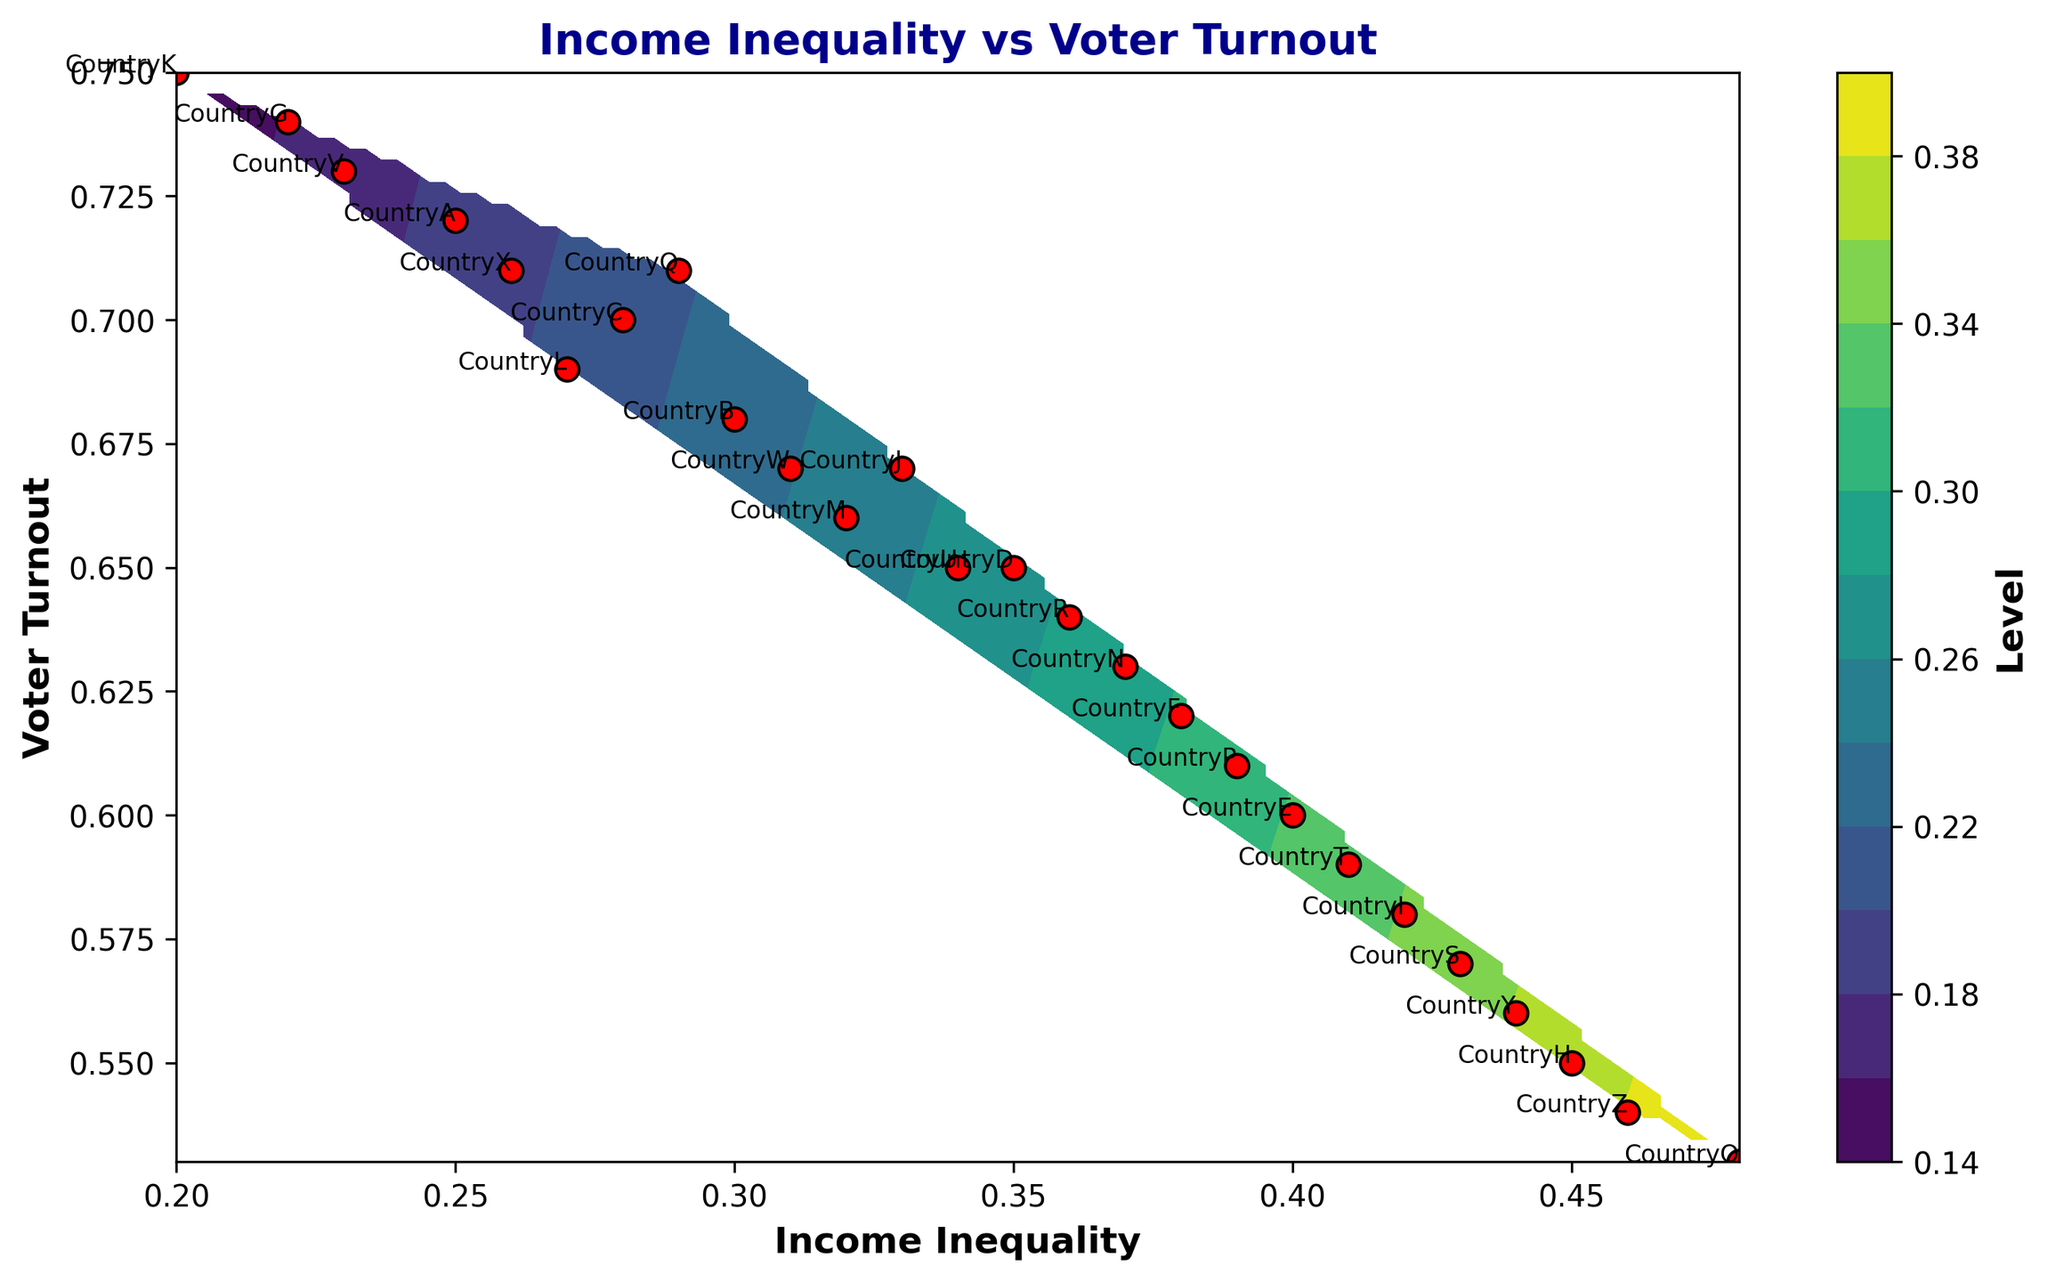What is the general trend between income inequality and voter turnout? By looking at the contour plot, the general trend appears to be that as income inequality increases, voter turnout tends to decrease. This is portrayed by the overall direction and shape of the contours.
Answer: As income inequality increases, voter turnout decreases Which country exhibits the highest voter turnout, and what is its corresponding income inequality? Referencing the scatter points on the plot, the country with the highest voter turnout is CountryK (0.75), which has an income inequality of 0.20.
Answer: CountryK; Income inequality 0.20 Which country has the highest income inequality, and what is its voter turnout rate? Observing the scatter points, CountryO has the highest income inequality at 0.48, and its corresponding voter turnout rate is 0.53.
Answer: CountryO; Voter turnout 0.53 What countries fall within the top 50% of the income inequality spectrum? Countries with the highest income inequalities are identified by values close to 0.48. These countries include CountryO, CountryZ, CountryY, CountryS, CountryT, and CountryI.
Answer: CountryO, CountryZ, CountryY, CountryS, CountryT, CountryI Are there any countries with similar income inequality yet significantly different voter turnout? Examining scatter points, countries with similar income inequalities but differing voter turnouts are Countries B and W, both with around 0.30 income inequality but their voter turnouts are 0.68 and 0.67 respectively.
Answer: CountryB and CountryW Based on the plot, can we identify any clusters of countries? There are clusters seen in the plot such as around (0.34, 0.65) to (0.38, 0.62), where multiple countries have similar levels of income inequalities and voter turnouts.
Answer: Yes; around (0.34, 0.65) to (0.38, 0.62) What’s the largest gap in voter turnout rate among countries with income inequality less than or equal to 0.25? The countries within this range are CountryA (0.72), CountryG (0.74), and CountryK (0.75). The largest gap in voter turnout between these countries is between CountryA (0.72) and CountryK (0.75), which is 0.75 - 0.72.
Answer: 0.03 how does the variability in voter turnout change with increasing income inequality? The scatter plot reveals that voter turnout has less variability with higher income inequality. Countries with income inequalities above 0.4 show less spread in voter turnout, typically from 0.53 to 0.59.
Answer: Decreases Are there any outliers in voter turnout or income inequality? Observing the scatter plot, CountryO stands out as an outlier in income inequality (0.48) while still having a consistent turnout (0.53). CountryK appears as an outlier in voter turnout (0.75) with low income inequality (0.20).
Answer: CountryO and CountryK 